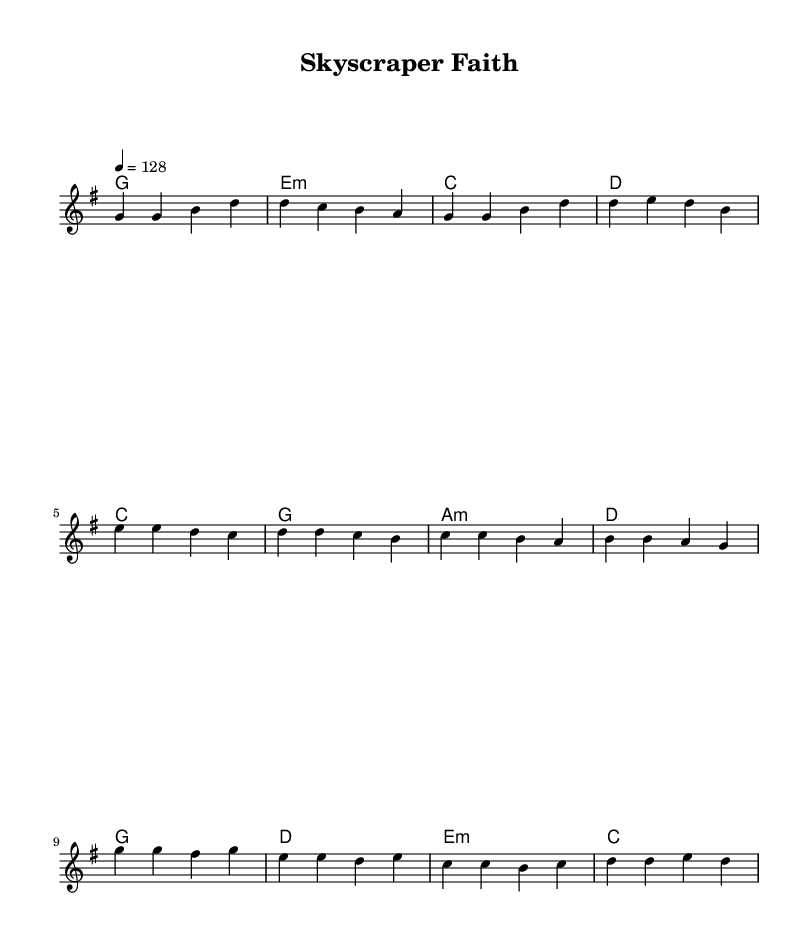What is the key signature of this music? The key signature is G major, which has one sharp (F#). This can be determined by looking at the initial part of the sheet music, where it specifies \key g \major.
Answer: G major What is the time signature of this piece? The time signature is 4/4, which indicates that there are four beats in each measure and the quarter note gets one beat. This is noted at the beginning of the musical notation with \time 4/4.
Answer: 4/4 What is the tempo of the piece? The tempo marking indicates a speed of 128 beats per minute, denoted by \tempo 4 = 128 in the score. This specifies the pace of the music during performance.
Answer: 128 What is the first note of the pre-chorus? The first note of the pre-chorus is E, as indicated in the melody section right after the verse ends. The melody notes start as E e d c for the pre-chorus lines.
Answer: E What is the last chord of the chorus? The last chord of the chorus is D. Looking at the chorus section under the harmonies, the last entry is "d d e d", indicating that the music resolves on the D chord.
Answer: D What theme do the lyrics of this song convey? The lyrics convey a theme of seeking purpose in a fast-paced professional environment, as demonstrated by phrases like "There's gotta be purpose" and "Your light guides me through each busy day". This reflects a spiritual quest amidst daily challenges.
Answer: Purpose 